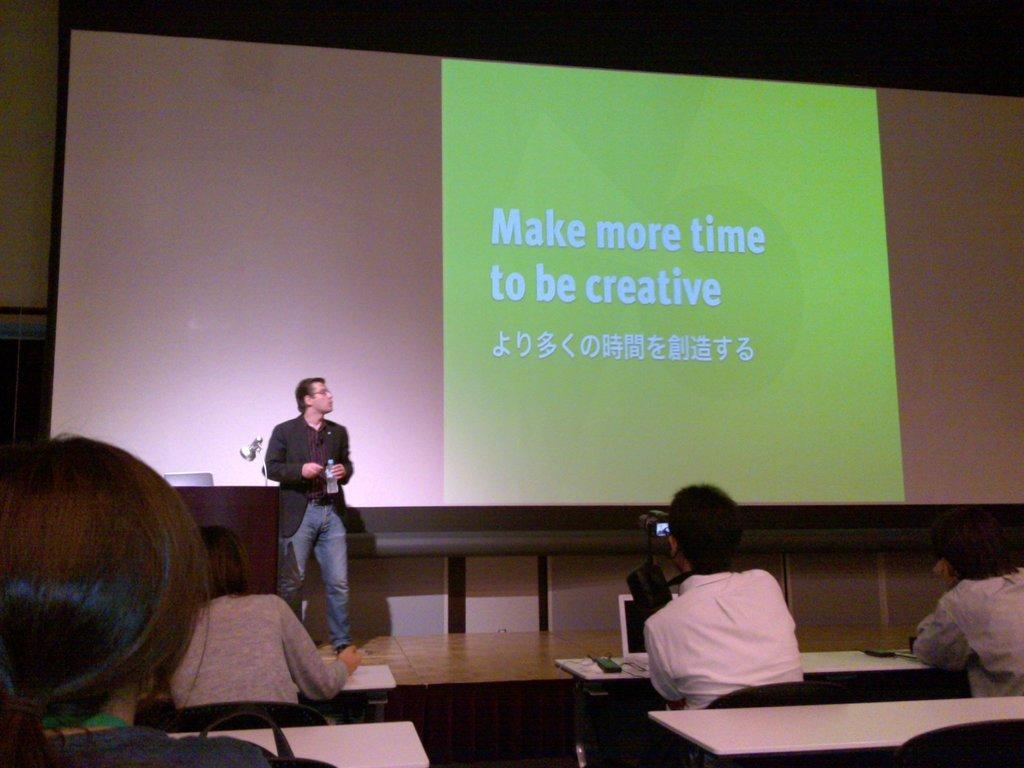<image>
Summarize the visual content of the image. Make more time to be creative is displayed on the presentation screen. 